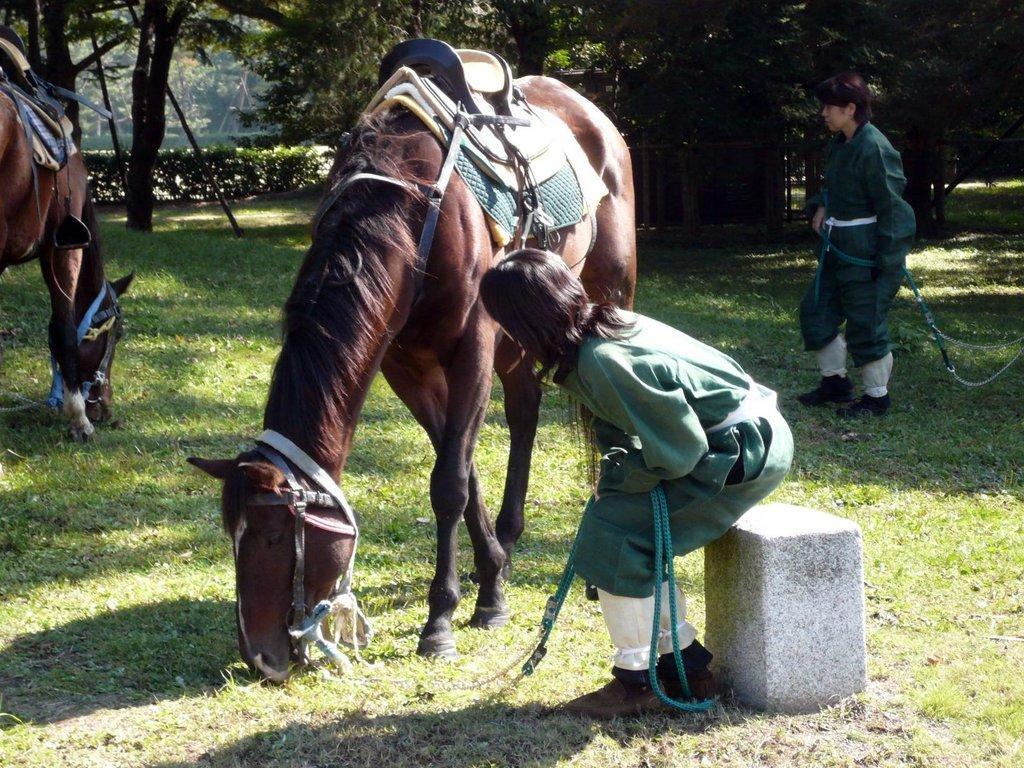Could you give a brief overview of what you see in this image? The picture is taken outside a ground. There are two horses in the image and there are two persons. The ground is full of grass. In the background there are trees. 